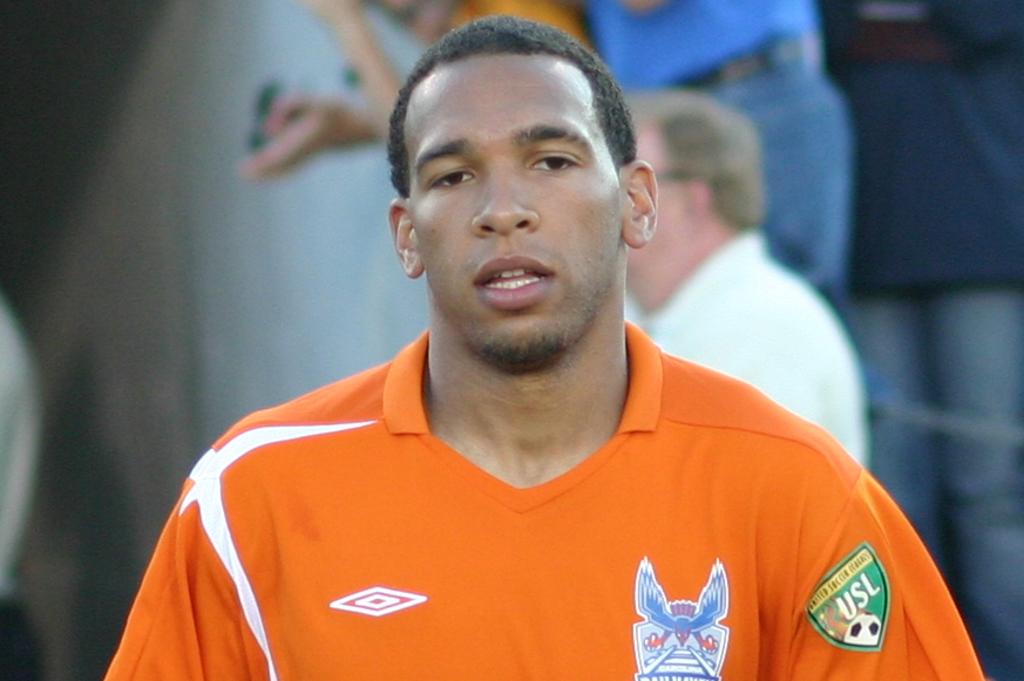What league is advertised on the green patch?
Offer a very short reply. Usl. 